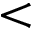Convert formula to latex. <formula><loc_0><loc_0><loc_500><loc_500><</formula> 